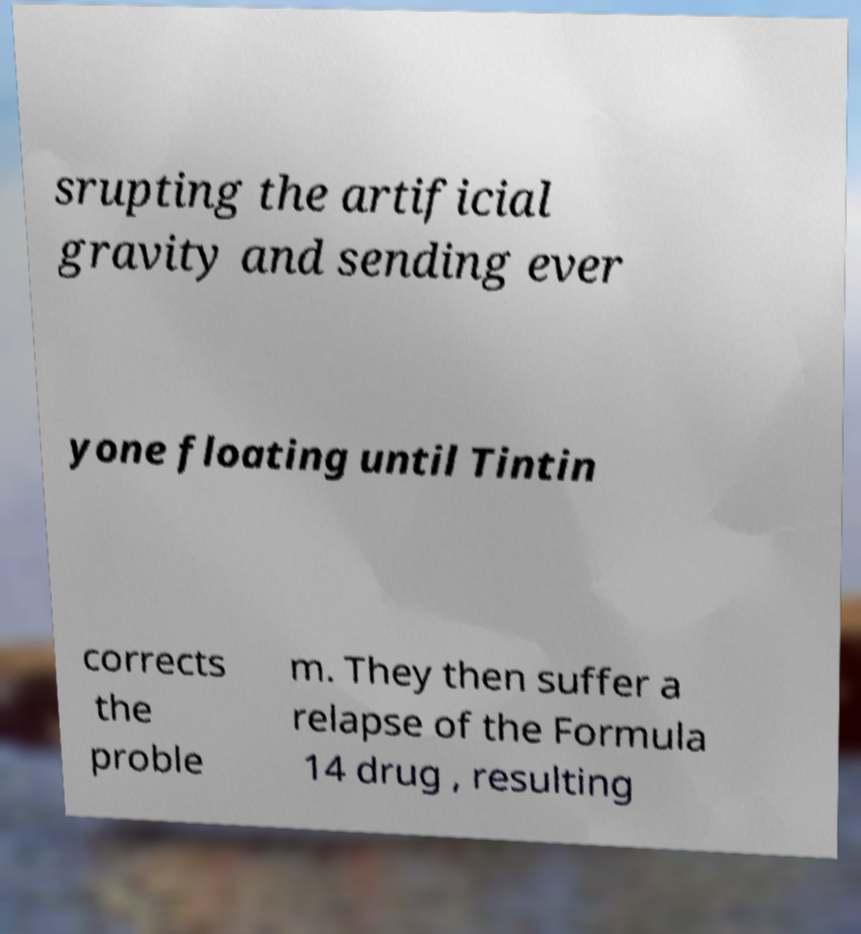Could you assist in decoding the text presented in this image and type it out clearly? srupting the artificial gravity and sending ever yone floating until Tintin corrects the proble m. They then suffer a relapse of the Formula 14 drug , resulting 